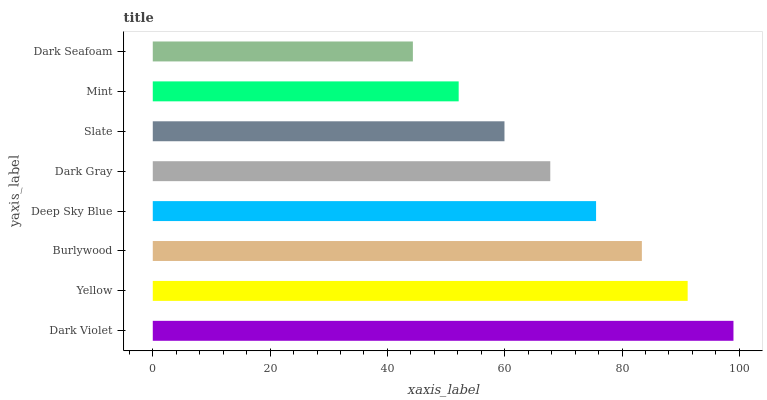Is Dark Seafoam the minimum?
Answer yes or no. Yes. Is Dark Violet the maximum?
Answer yes or no. Yes. Is Yellow the minimum?
Answer yes or no. No. Is Yellow the maximum?
Answer yes or no. No. Is Dark Violet greater than Yellow?
Answer yes or no. Yes. Is Yellow less than Dark Violet?
Answer yes or no. Yes. Is Yellow greater than Dark Violet?
Answer yes or no. No. Is Dark Violet less than Yellow?
Answer yes or no. No. Is Deep Sky Blue the high median?
Answer yes or no. Yes. Is Dark Gray the low median?
Answer yes or no. Yes. Is Dark Seafoam the high median?
Answer yes or no. No. Is Mint the low median?
Answer yes or no. No. 